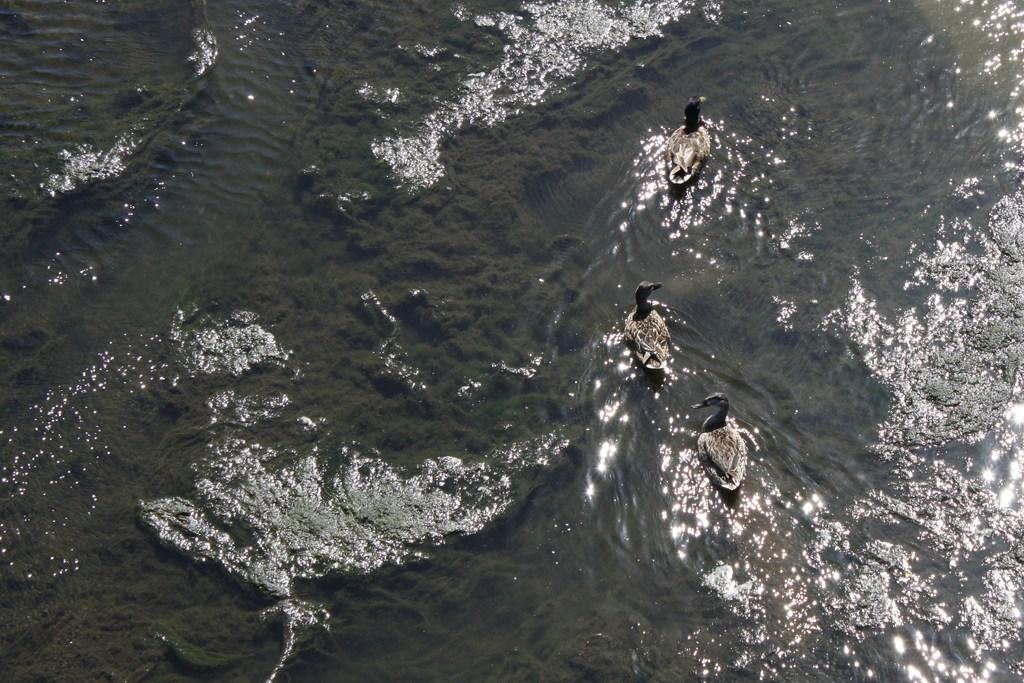What type of animals can be seen in the image? There are ducks in the image. Where are the ducks located? The ducks are on the water. What type of engine is powering the ducks in the image? There is no engine present in the image, as ducks are living creatures and do not require engines for movement. 